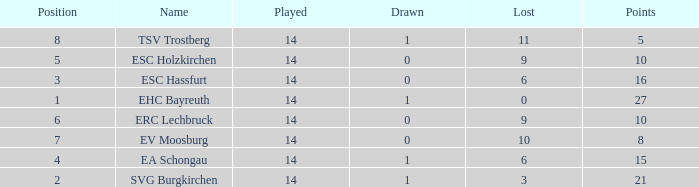What's the most points for Ea Schongau with more than 1 drawn? None. Would you be able to parse every entry in this table? {'header': ['Position', 'Name', 'Played', 'Drawn', 'Lost', 'Points'], 'rows': [['8', 'TSV Trostberg', '14', '1', '11', '5'], ['5', 'ESC Holzkirchen', '14', '0', '9', '10'], ['3', 'ESC Hassfurt', '14', '0', '6', '16'], ['1', 'EHC Bayreuth', '14', '1', '0', '27'], ['6', 'ERC Lechbruck', '14', '0', '9', '10'], ['7', 'EV Moosburg', '14', '0', '10', '8'], ['4', 'EA Schongau', '14', '1', '6', '15'], ['2', 'SVG Burgkirchen', '14', '1', '3', '21']]} 